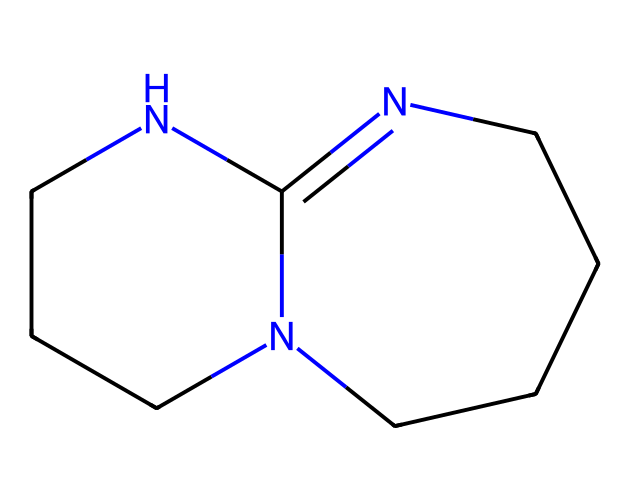What is the molecular formula of TBD? By analyzing the structure represented by the SMILES, we can count the number of carbon (C), nitrogen (N), and hydrogen (H) atoms. The structure shows 6 carbon atoms, 6 hydrogen atoms, and 3 nitrogen atoms, leading to the molecular formula C6H10N4.
Answer: C6H10N4 How many carbon atoms are in the structure? In the SMILES representation, we can identify all 'C' characters, totaling 6 carbon atoms present in the chemical structure.
Answer: 6 What type of heteroatoms are present in this molecular structure? The SMILES contains 'N' characters, indicating the presence of nitrogen as the only heteroatom in this structure. There are no other heteroatoms present since only nitrogen is observed.
Answer: nitrogen How many nitrogen atoms are present in TBD? By counting the 'N' symbols in the SMILES representation, we find there are 4 nitrogen atoms present in the chemical structure.
Answer: 4 What makes TBD a superbase? TBD has a unique bicyclic structure with multiple nitrogen atoms that are highly nucleophilic, increasing its capacity to deprotonate weak acids, which classifies it as a superbase.
Answer: nucleophilic nitrogen What is the significance of the bicyclic structure in TBD? The bicyclic structure facilitates better overlap of orbitals and delocalization of electrons across the nitrogen atoms, resulting in enhanced basicity and increased reactivity in biodiesel production processes.
Answer: enhanced basicity How many rings are present in the molecular structure of TBD? Observing the bicyclic nature of the structure, we identify that there are 2 rings formed by the carbon and nitrogen atoms in TBD.
Answer: 2 